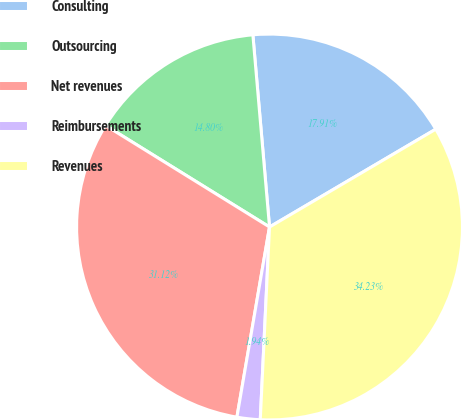Convert chart to OTSL. <chart><loc_0><loc_0><loc_500><loc_500><pie_chart><fcel>Consulting<fcel>Outsourcing<fcel>Net revenues<fcel>Reimbursements<fcel>Revenues<nl><fcel>17.91%<fcel>14.8%<fcel>31.12%<fcel>1.94%<fcel>34.23%<nl></chart> 